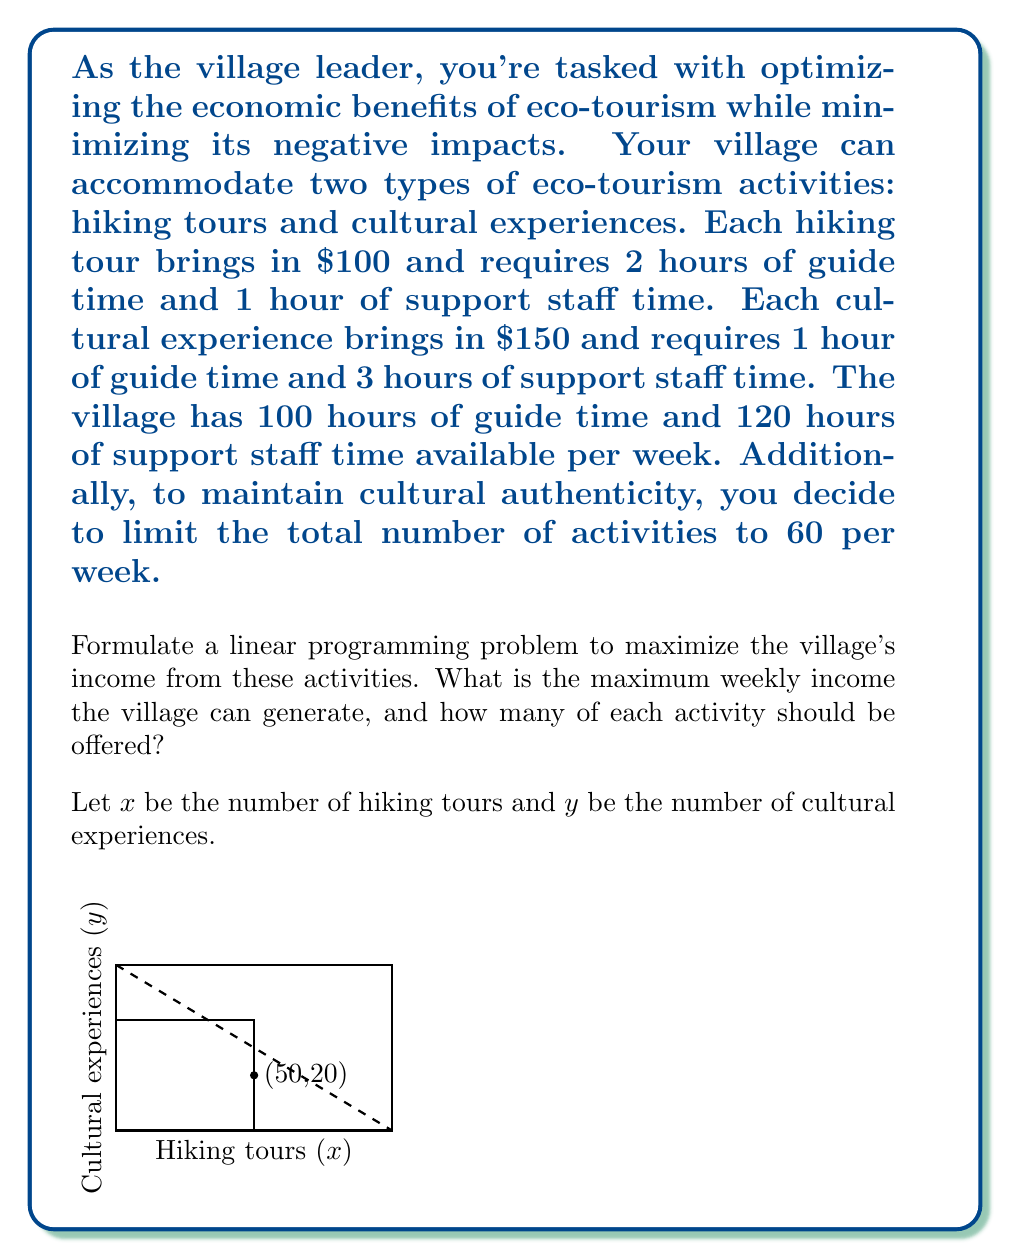Teach me how to tackle this problem. Let's approach this step-by-step:

1) First, we need to formulate the objective function. We want to maximize income:
   
   Maximize: $Z = 100x + 150y$

2) Now, let's list our constraints:

   a) Guide time: $2x + y ≤ 100$
   b) Support staff time: $x + 3y ≤ 120$
   c) Total activities: $x + y ≤ 60$
   d) Non-negativity: $x ≥ 0, y ≥ 0$

3) This forms our complete linear programming problem. To solve it, we can use the graphical method or the simplex method. In this case, let's use the graphical method.

4) Plot the constraints on a graph (as shown in the question). The feasible region is the area that satisfies all constraints.

5) The optimal solution will be at one of the corner points of the feasible region. The corner points are:
   (0,0), (0,40), (50,20), (60,0)

6) Evaluate the objective function at each point:
   
   At (0,0): $Z = 0$
   At (0,40): $Z = 6000$
   At (50,20): $Z = 8000$
   At (60,0): $Z = 6000$

7) The maximum value occurs at (50,20), which means 50 hiking tours and 20 cultural experiences.

8) The maximum weekly income is therefore:
   $Z = 100(50) + 150(20) = 5000 + 3000 = 8000$
Answer: $8000; 50 hiking tours and 20 cultural experiences 